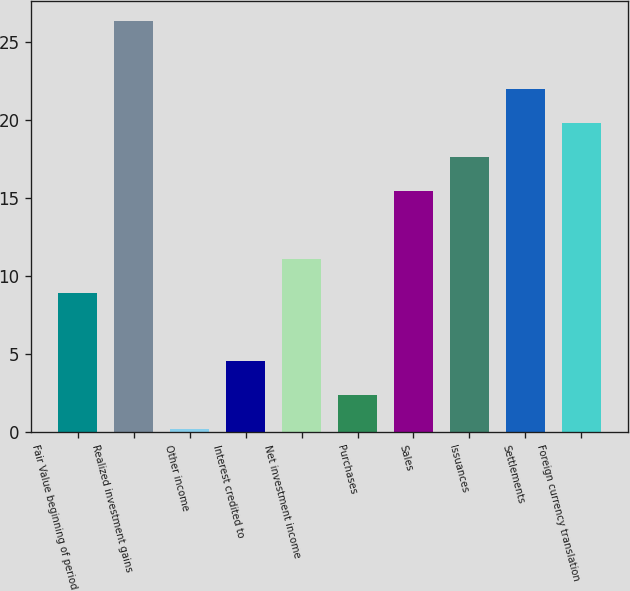Convert chart to OTSL. <chart><loc_0><loc_0><loc_500><loc_500><bar_chart><fcel>Fair Value beginning of period<fcel>Realized investment gains<fcel>Other income<fcel>Interest credited to<fcel>Net investment income<fcel>Purchases<fcel>Sales<fcel>Issuances<fcel>Settlements<fcel>Foreign currency translation<nl><fcel>8.9<fcel>26.34<fcel>0.18<fcel>4.54<fcel>11.08<fcel>2.36<fcel>15.44<fcel>17.62<fcel>21.98<fcel>19.8<nl></chart> 